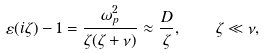Convert formula to latex. <formula><loc_0><loc_0><loc_500><loc_500>\varepsilon ( i \zeta ) - 1 = \frac { \omega _ { p } ^ { 2 } } { \zeta ( \zeta + \nu ) } \approx \frac { D } { \zeta } , \quad \zeta \ll \nu ,</formula> 